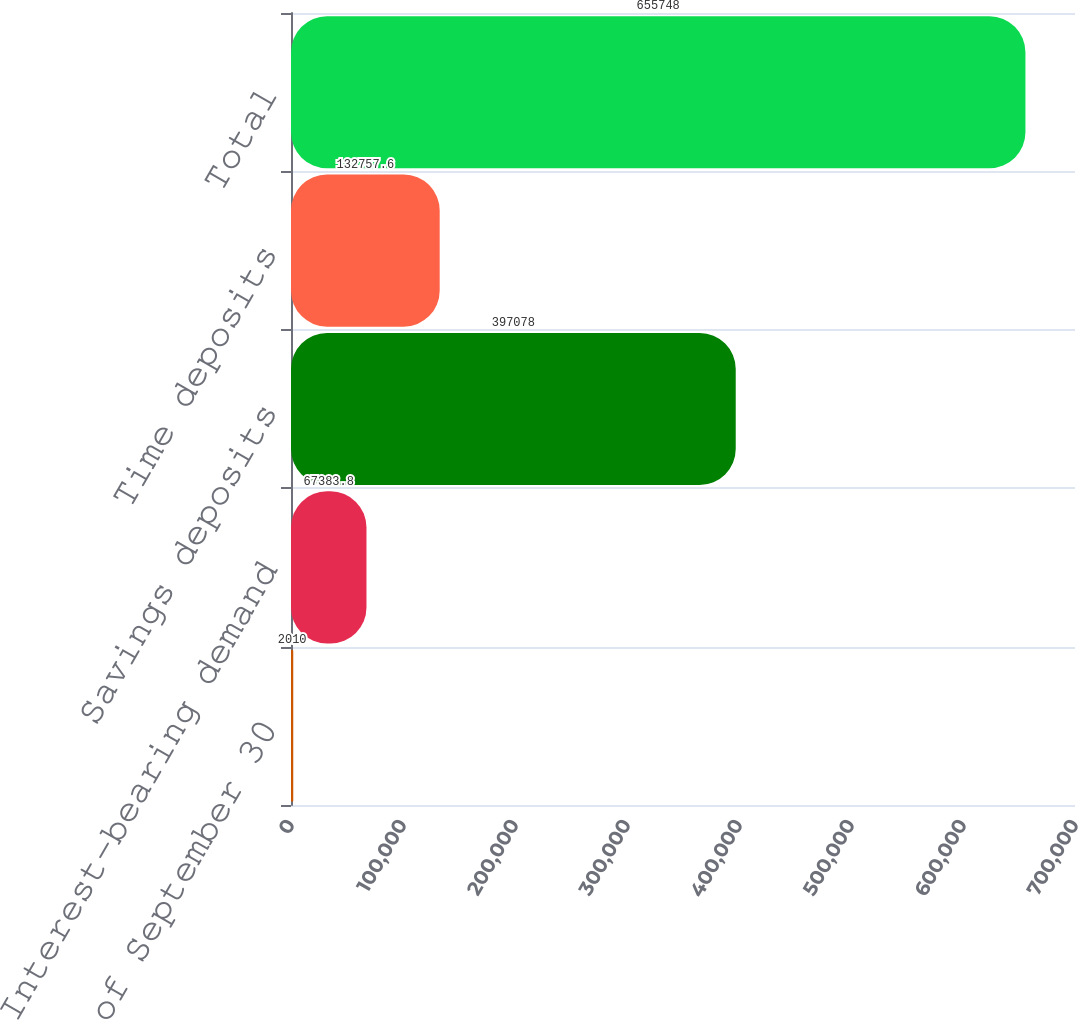Convert chart to OTSL. <chart><loc_0><loc_0><loc_500><loc_500><bar_chart><fcel>as of September 30<fcel>Interest-bearing demand<fcel>Savings deposits<fcel>Time deposits<fcel>Total<nl><fcel>2010<fcel>67383.8<fcel>397078<fcel>132758<fcel>655748<nl></chart> 